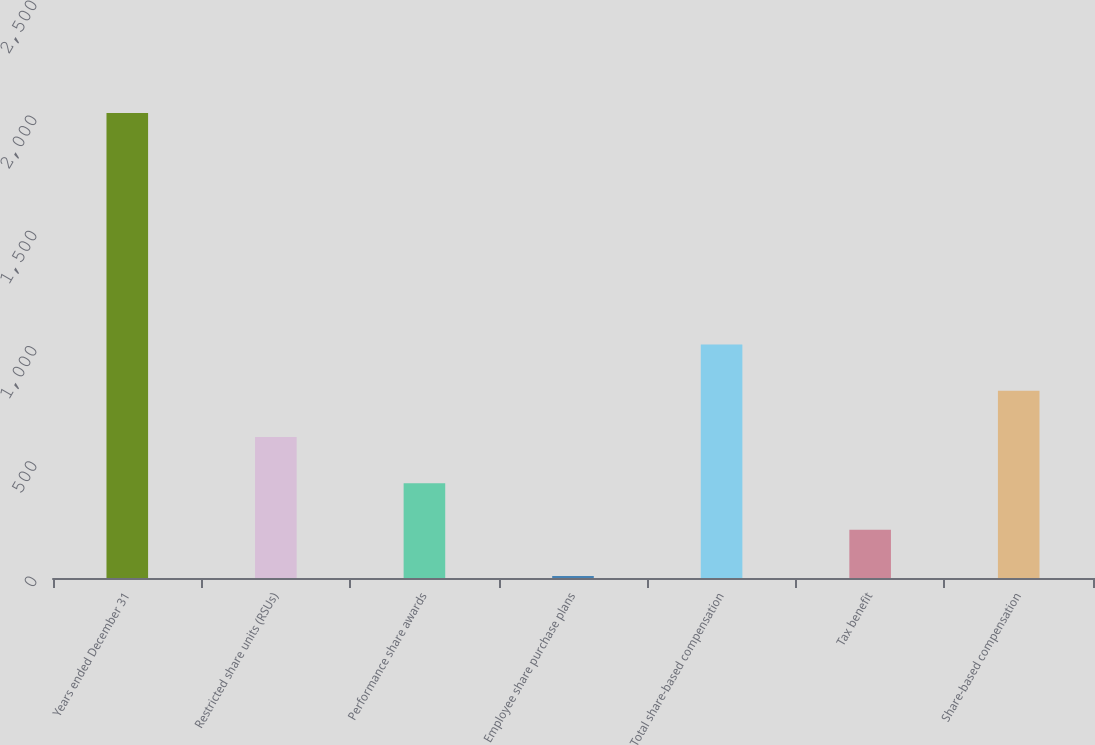Convert chart. <chart><loc_0><loc_0><loc_500><loc_500><bar_chart><fcel>Years ended December 31<fcel>Restricted share units (RSUs)<fcel>Performance share awards<fcel>Employee share purchase plans<fcel>Total share-based compensation<fcel>Tax benefit<fcel>Share-based compensation<nl><fcel>2018<fcel>611.7<fcel>410.8<fcel>9<fcel>1013.5<fcel>209.9<fcel>812.6<nl></chart> 